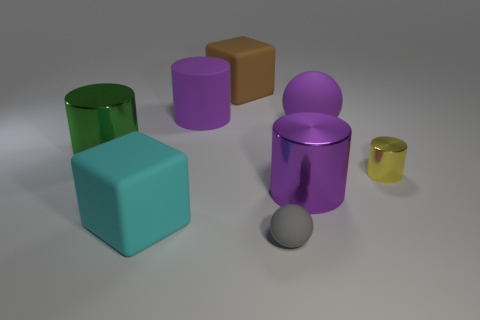What number of other objects are there of the same shape as the big green object?
Provide a short and direct response. 3. There is a cylinder that is in front of the green object and to the left of the large purple sphere; what material is it made of?
Your response must be concise. Metal. How many matte blocks have the same size as the cyan thing?
Give a very brief answer. 1. There is a small yellow thing that is the same shape as the large green thing; what material is it?
Your answer should be very brief. Metal. How many objects are purple matte things that are to the left of the big sphere or large matte things in front of the purple metal cylinder?
Make the answer very short. 2. There is a tiny yellow thing; does it have the same shape as the brown thing behind the big purple matte cylinder?
Provide a short and direct response. No. What is the shape of the small gray object that is to the right of the big cylinder that is behind the purple matte object that is right of the brown matte cube?
Offer a terse response. Sphere. How many other objects are the same material as the gray object?
Make the answer very short. 4. What number of things are matte balls right of the gray thing or big yellow rubber cubes?
Keep it short and to the point. 1. What is the shape of the purple matte object left of the large matte cube that is behind the purple matte cylinder?
Make the answer very short. Cylinder. 